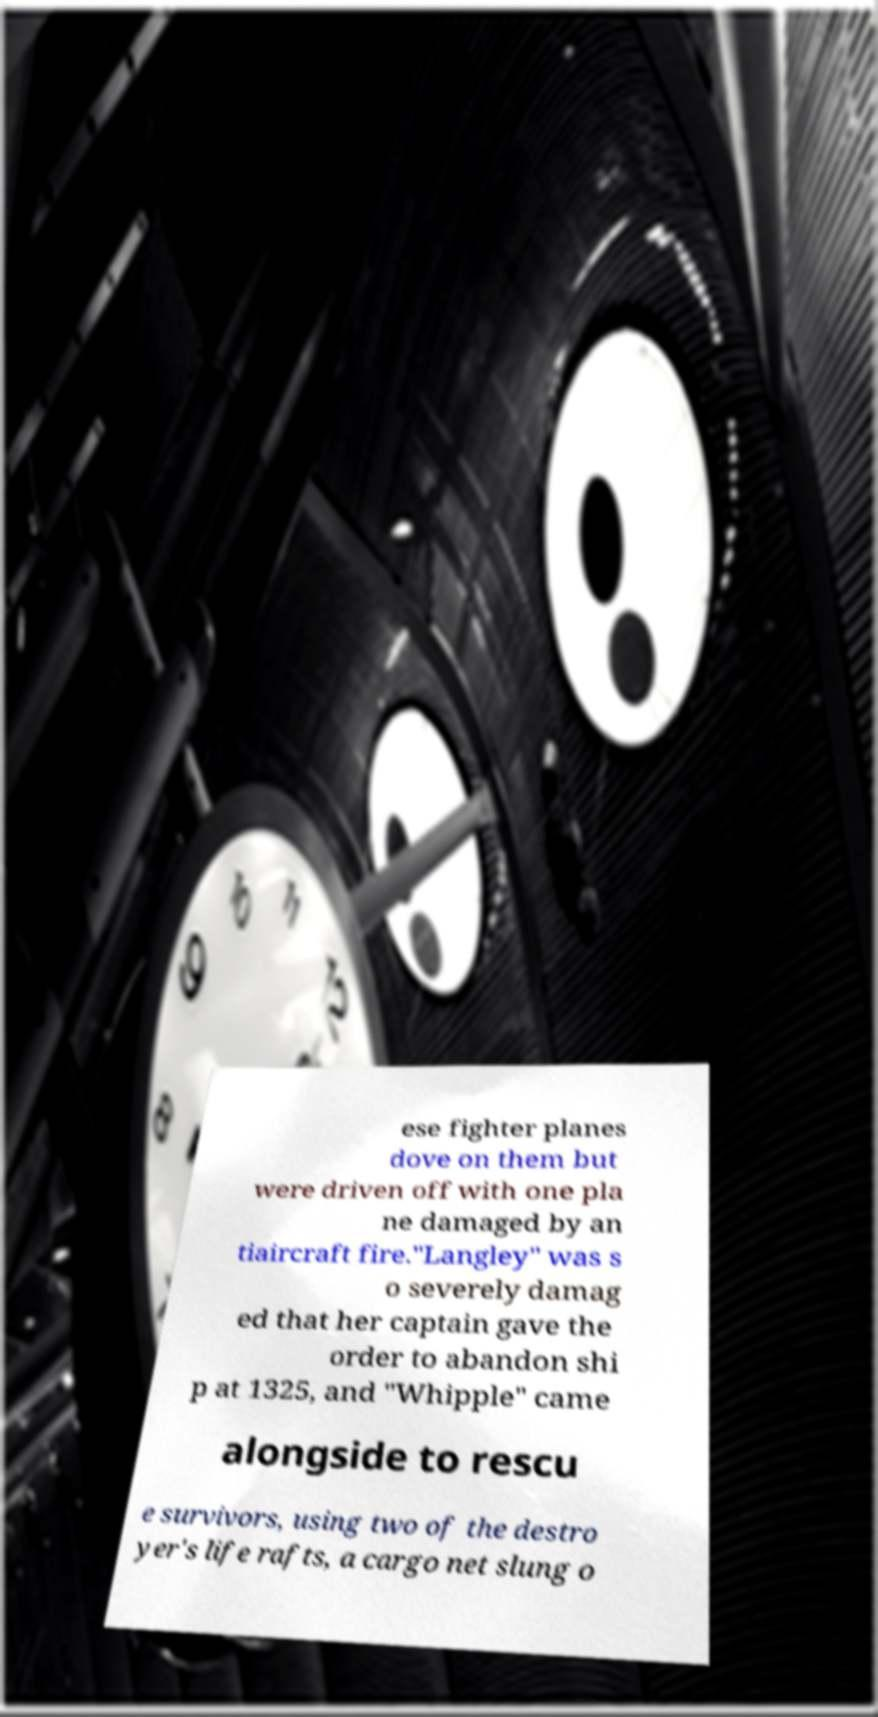I need the written content from this picture converted into text. Can you do that? ese fighter planes dove on them but were driven off with one pla ne damaged by an tiaircraft fire."Langley" was s o severely damag ed that her captain gave the order to abandon shi p at 1325, and "Whipple" came alongside to rescu e survivors, using two of the destro yer's life rafts, a cargo net slung o 